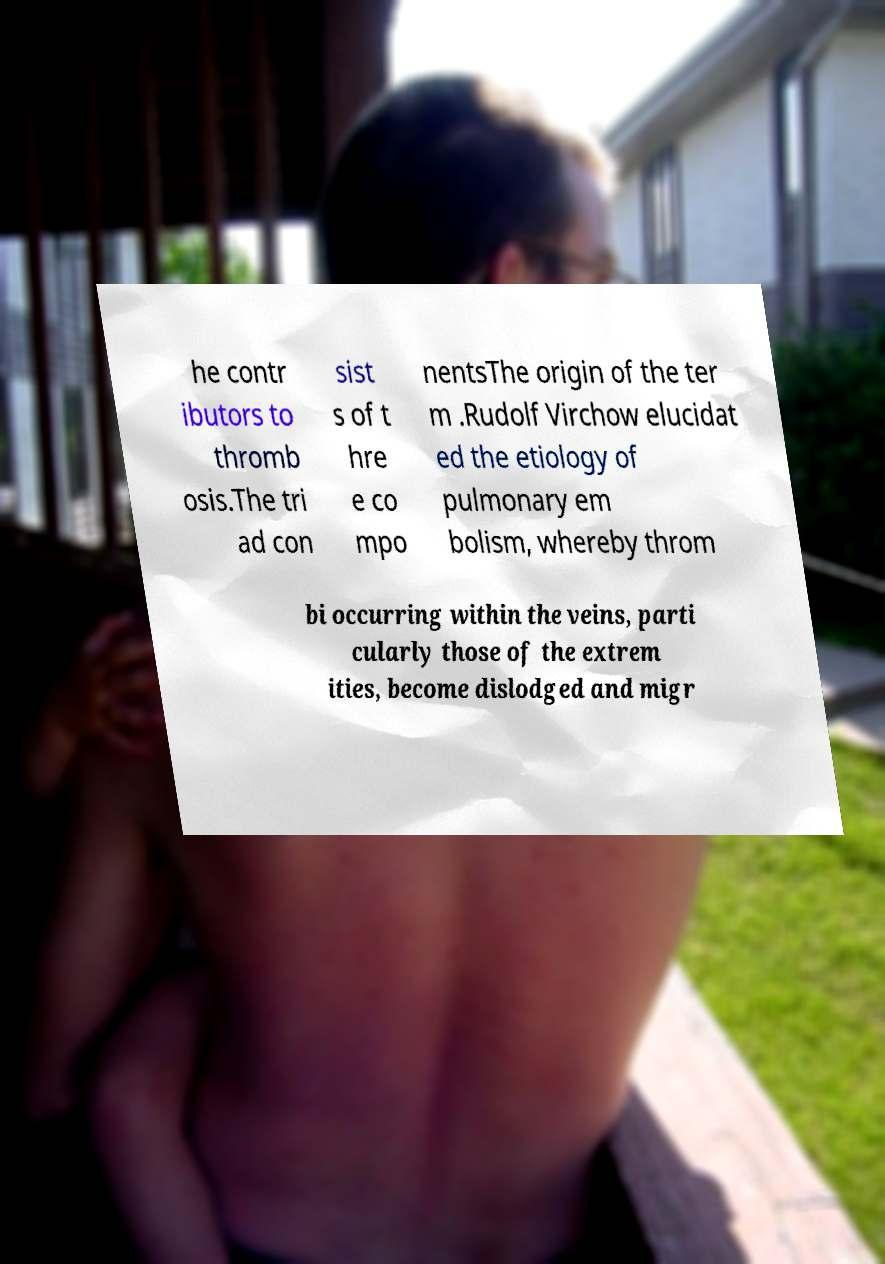Could you extract and type out the text from this image? he contr ibutors to thromb osis.The tri ad con sist s of t hre e co mpo nentsThe origin of the ter m .Rudolf Virchow elucidat ed the etiology of pulmonary em bolism, whereby throm bi occurring within the veins, parti cularly those of the extrem ities, become dislodged and migr 